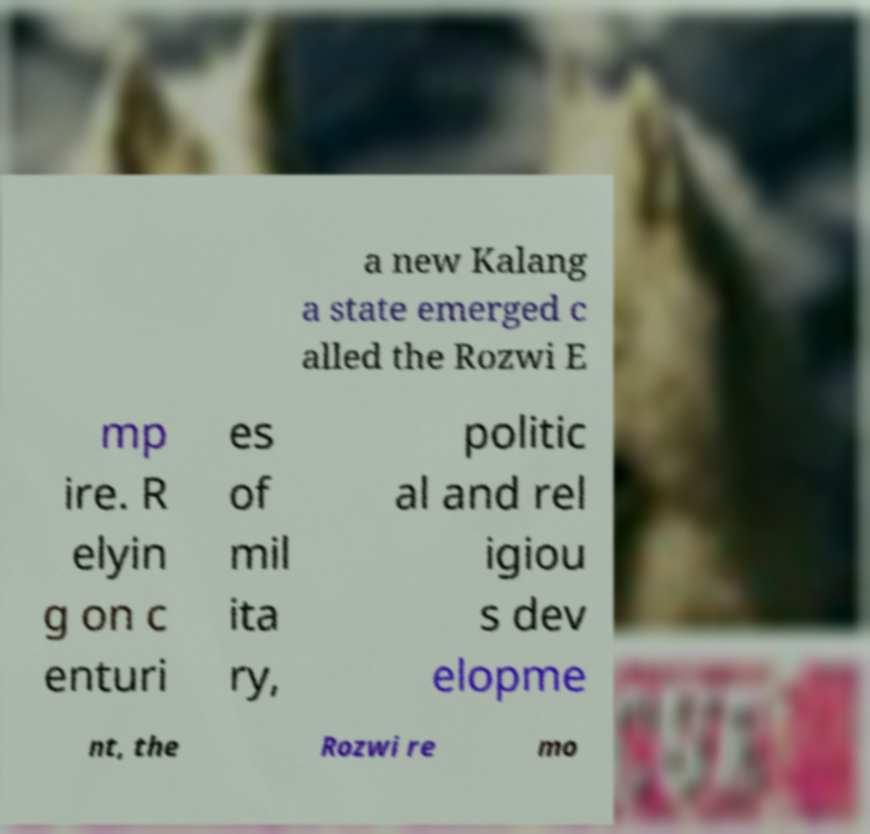Please read and relay the text visible in this image. What does it say? a new Kalang a state emerged c alled the Rozwi E mp ire. R elyin g on c enturi es of mil ita ry, politic al and rel igiou s dev elopme nt, the Rozwi re mo 